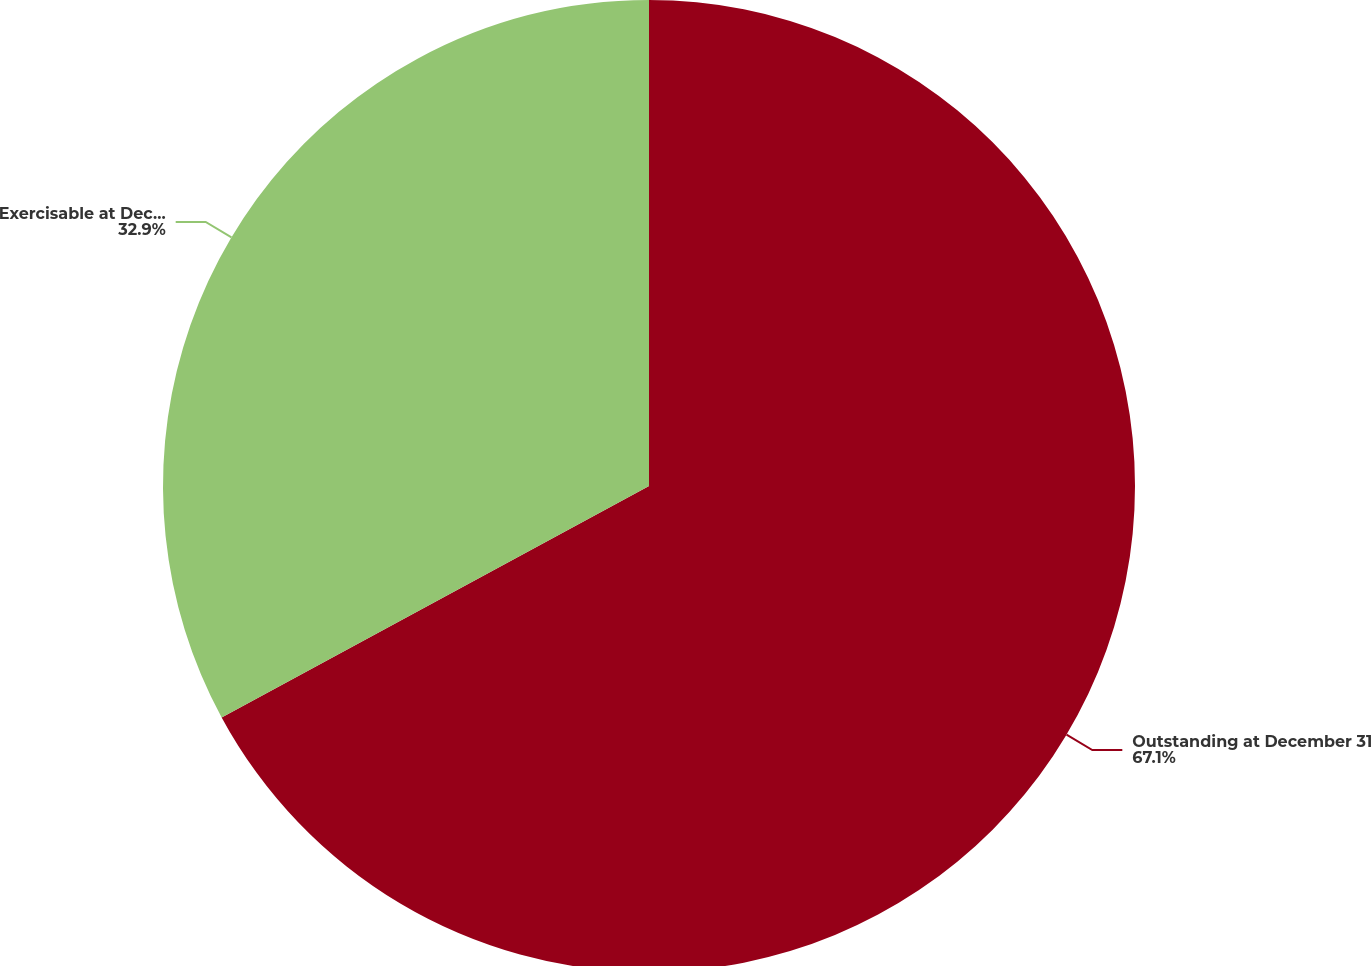Convert chart to OTSL. <chart><loc_0><loc_0><loc_500><loc_500><pie_chart><fcel>Outstanding at December 31<fcel>Exercisable at December 31<nl><fcel>67.1%<fcel>32.9%<nl></chart> 